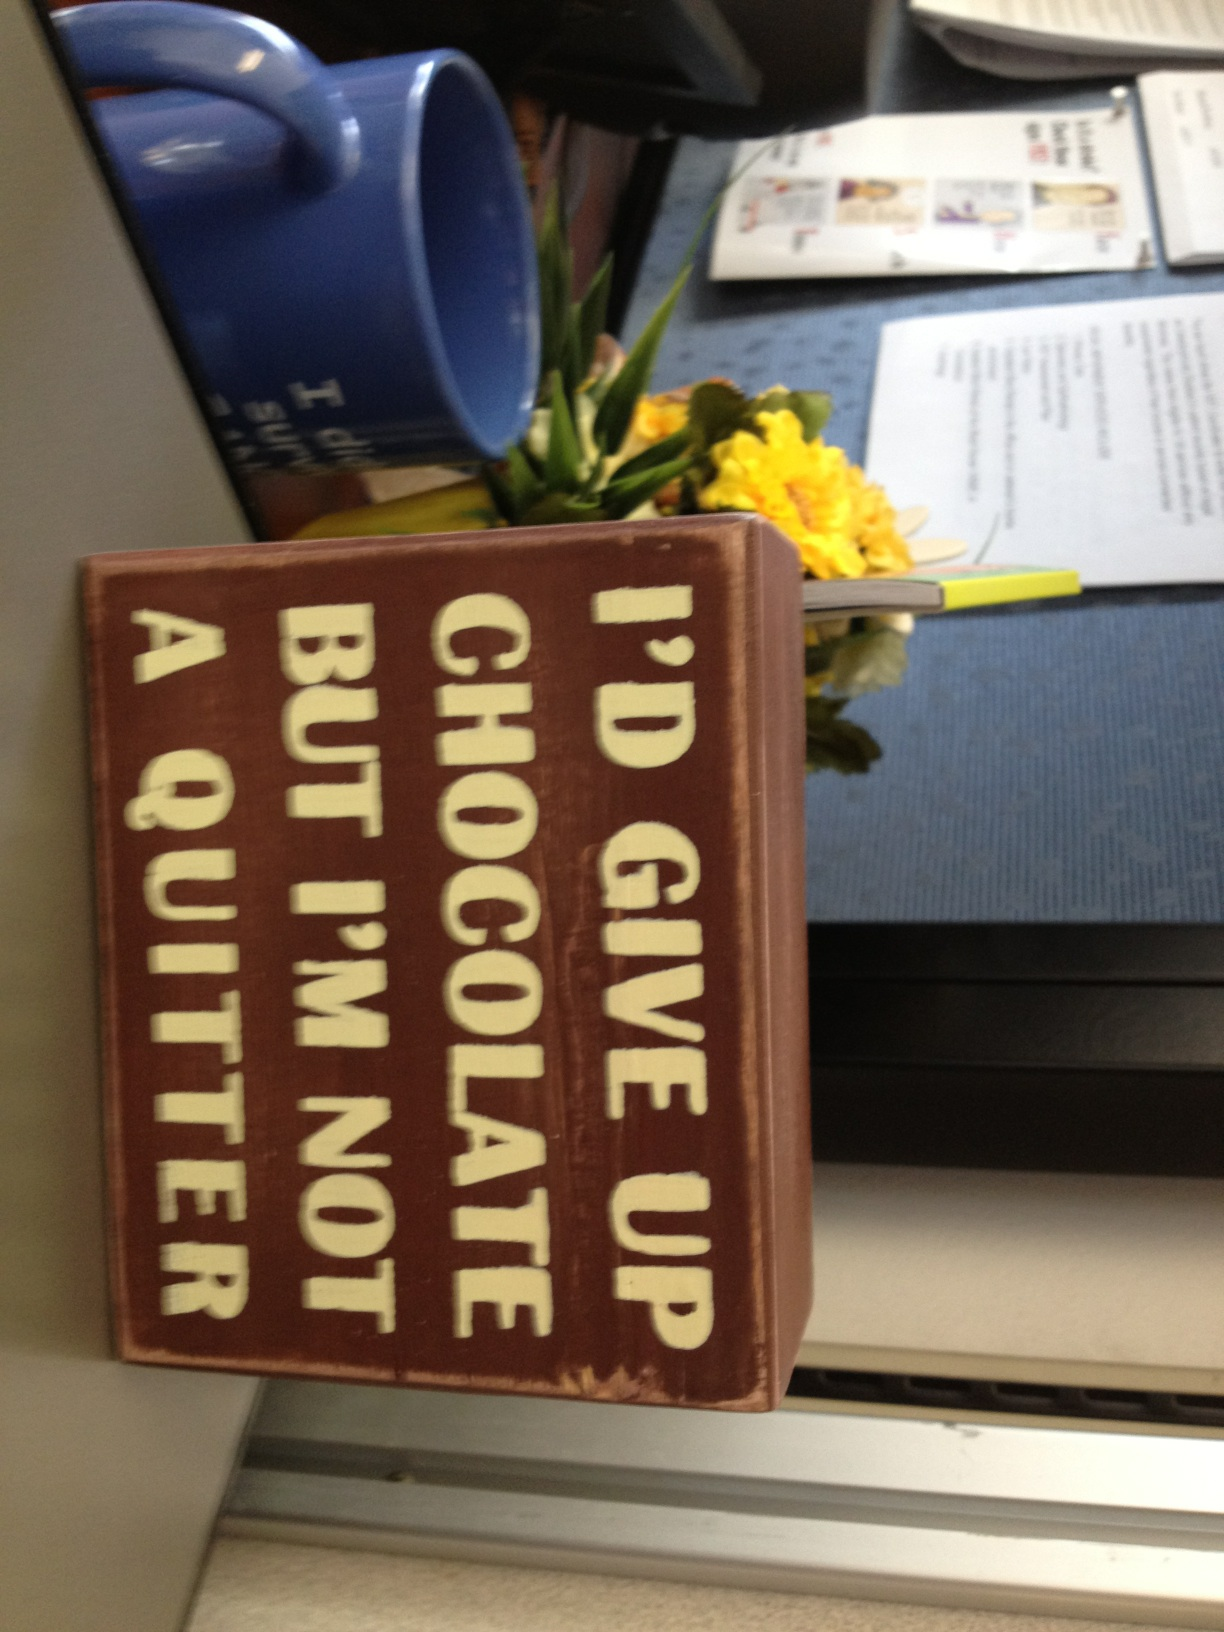what does this say? The text on the sign says, 'I’d give up chocolate but I’m not a quitter.' 